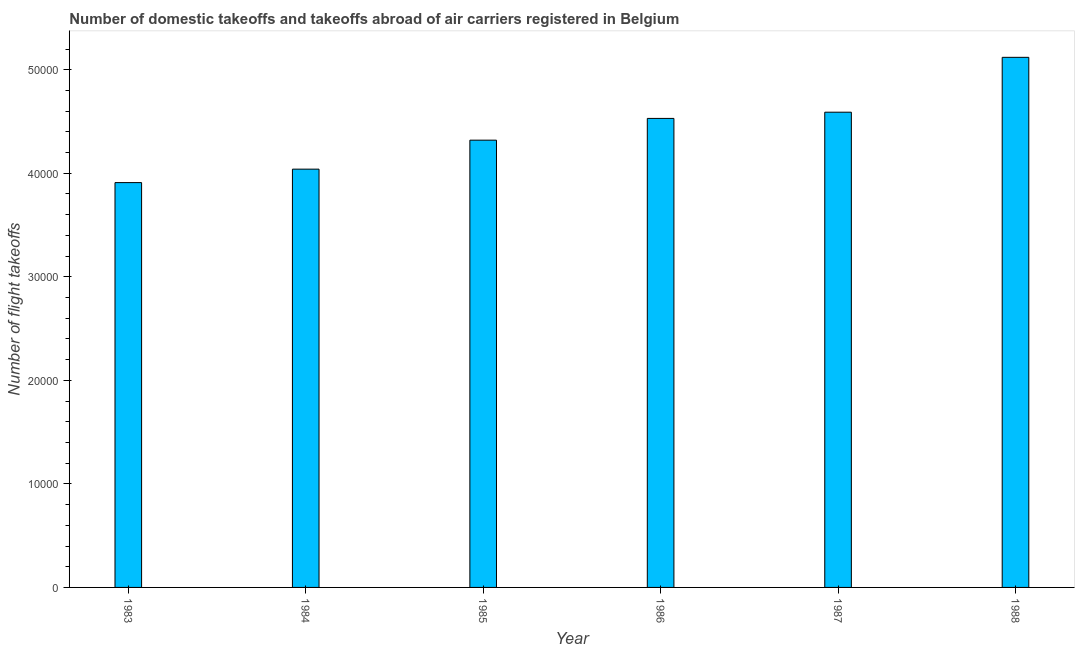Does the graph contain any zero values?
Give a very brief answer. No. Does the graph contain grids?
Your response must be concise. No. What is the title of the graph?
Your response must be concise. Number of domestic takeoffs and takeoffs abroad of air carriers registered in Belgium. What is the label or title of the Y-axis?
Keep it short and to the point. Number of flight takeoffs. What is the number of flight takeoffs in 1986?
Your answer should be very brief. 4.53e+04. Across all years, what is the maximum number of flight takeoffs?
Offer a very short reply. 5.12e+04. Across all years, what is the minimum number of flight takeoffs?
Provide a short and direct response. 3.91e+04. In which year was the number of flight takeoffs maximum?
Provide a succinct answer. 1988. In which year was the number of flight takeoffs minimum?
Provide a short and direct response. 1983. What is the sum of the number of flight takeoffs?
Your answer should be compact. 2.65e+05. What is the difference between the number of flight takeoffs in 1983 and 1984?
Your response must be concise. -1300. What is the average number of flight takeoffs per year?
Provide a succinct answer. 4.42e+04. What is the median number of flight takeoffs?
Provide a short and direct response. 4.42e+04. In how many years, is the number of flight takeoffs greater than 44000 ?
Provide a succinct answer. 3. What is the difference between the highest and the second highest number of flight takeoffs?
Offer a very short reply. 5300. What is the difference between the highest and the lowest number of flight takeoffs?
Keep it short and to the point. 1.21e+04. What is the difference between two consecutive major ticks on the Y-axis?
Provide a succinct answer. 10000. What is the Number of flight takeoffs in 1983?
Your response must be concise. 3.91e+04. What is the Number of flight takeoffs of 1984?
Offer a terse response. 4.04e+04. What is the Number of flight takeoffs in 1985?
Keep it short and to the point. 4.32e+04. What is the Number of flight takeoffs in 1986?
Your answer should be very brief. 4.53e+04. What is the Number of flight takeoffs of 1987?
Keep it short and to the point. 4.59e+04. What is the Number of flight takeoffs in 1988?
Ensure brevity in your answer.  5.12e+04. What is the difference between the Number of flight takeoffs in 1983 and 1984?
Provide a short and direct response. -1300. What is the difference between the Number of flight takeoffs in 1983 and 1985?
Make the answer very short. -4100. What is the difference between the Number of flight takeoffs in 1983 and 1986?
Give a very brief answer. -6200. What is the difference between the Number of flight takeoffs in 1983 and 1987?
Keep it short and to the point. -6800. What is the difference between the Number of flight takeoffs in 1983 and 1988?
Your answer should be compact. -1.21e+04. What is the difference between the Number of flight takeoffs in 1984 and 1985?
Offer a very short reply. -2800. What is the difference between the Number of flight takeoffs in 1984 and 1986?
Ensure brevity in your answer.  -4900. What is the difference between the Number of flight takeoffs in 1984 and 1987?
Ensure brevity in your answer.  -5500. What is the difference between the Number of flight takeoffs in 1984 and 1988?
Provide a succinct answer. -1.08e+04. What is the difference between the Number of flight takeoffs in 1985 and 1986?
Make the answer very short. -2100. What is the difference between the Number of flight takeoffs in 1985 and 1987?
Your answer should be very brief. -2700. What is the difference between the Number of flight takeoffs in 1985 and 1988?
Provide a succinct answer. -8000. What is the difference between the Number of flight takeoffs in 1986 and 1987?
Offer a terse response. -600. What is the difference between the Number of flight takeoffs in 1986 and 1988?
Offer a very short reply. -5900. What is the difference between the Number of flight takeoffs in 1987 and 1988?
Give a very brief answer. -5300. What is the ratio of the Number of flight takeoffs in 1983 to that in 1985?
Your answer should be compact. 0.91. What is the ratio of the Number of flight takeoffs in 1983 to that in 1986?
Offer a very short reply. 0.86. What is the ratio of the Number of flight takeoffs in 1983 to that in 1987?
Give a very brief answer. 0.85. What is the ratio of the Number of flight takeoffs in 1983 to that in 1988?
Offer a very short reply. 0.76. What is the ratio of the Number of flight takeoffs in 1984 to that in 1985?
Provide a succinct answer. 0.94. What is the ratio of the Number of flight takeoffs in 1984 to that in 1986?
Keep it short and to the point. 0.89. What is the ratio of the Number of flight takeoffs in 1984 to that in 1987?
Your answer should be compact. 0.88. What is the ratio of the Number of flight takeoffs in 1984 to that in 1988?
Give a very brief answer. 0.79. What is the ratio of the Number of flight takeoffs in 1985 to that in 1986?
Give a very brief answer. 0.95. What is the ratio of the Number of flight takeoffs in 1985 to that in 1987?
Your answer should be very brief. 0.94. What is the ratio of the Number of flight takeoffs in 1985 to that in 1988?
Offer a terse response. 0.84. What is the ratio of the Number of flight takeoffs in 1986 to that in 1988?
Offer a very short reply. 0.89. What is the ratio of the Number of flight takeoffs in 1987 to that in 1988?
Offer a terse response. 0.9. 